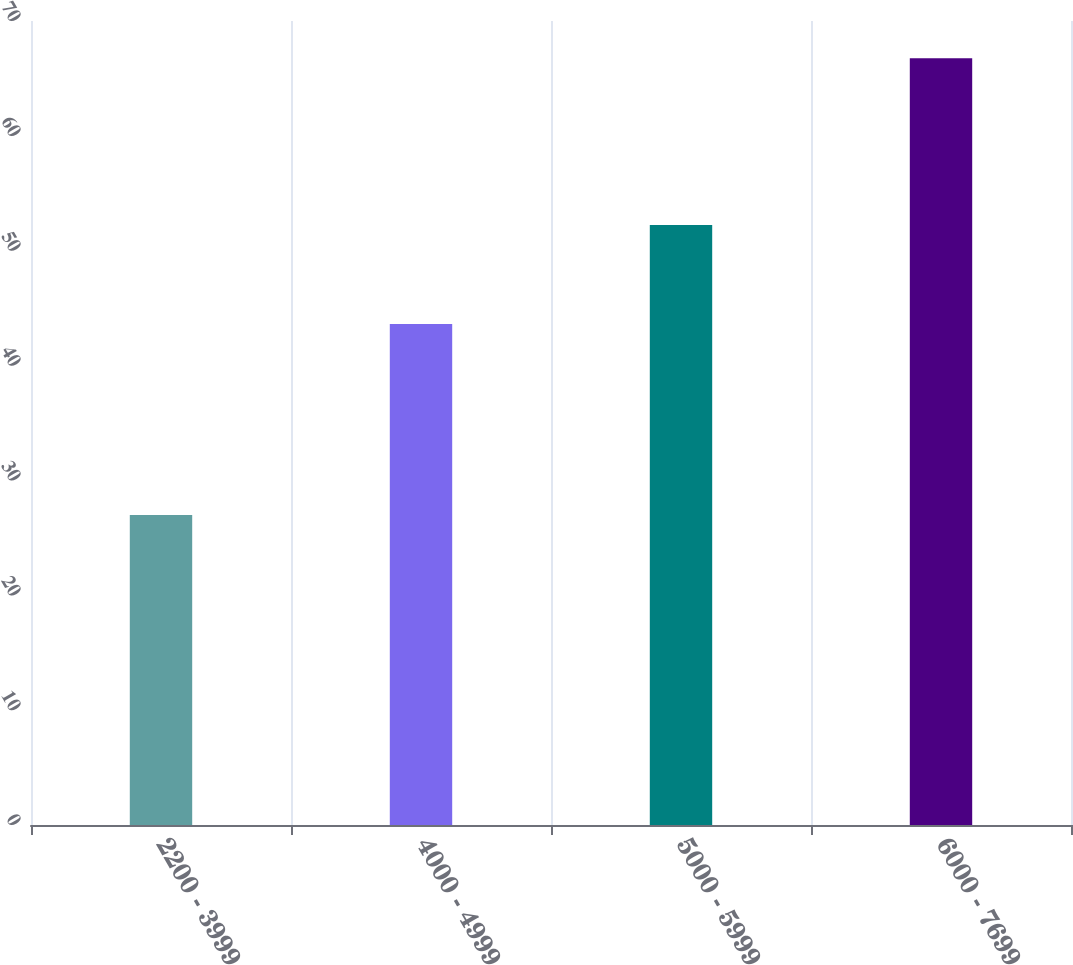Convert chart to OTSL. <chart><loc_0><loc_0><loc_500><loc_500><bar_chart><fcel>2200 - 3999<fcel>4000 - 4999<fcel>5000 - 5999<fcel>6000 - 7699<nl><fcel>26.98<fcel>43.62<fcel>52.23<fcel>66.75<nl></chart> 